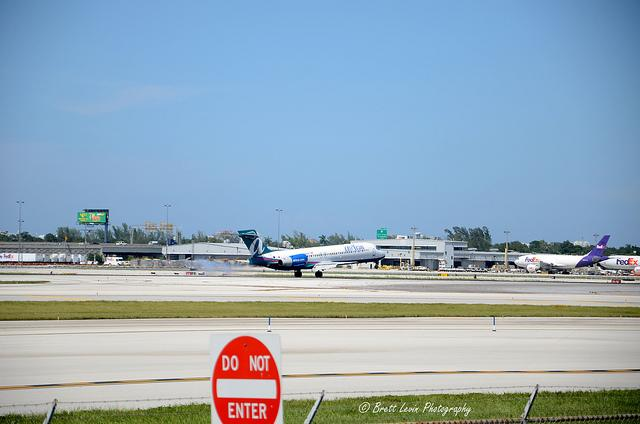What color is the FedEx airplane's tail fin?

Choices:
A) blue
B) green
C) yellow
D) purple purple 